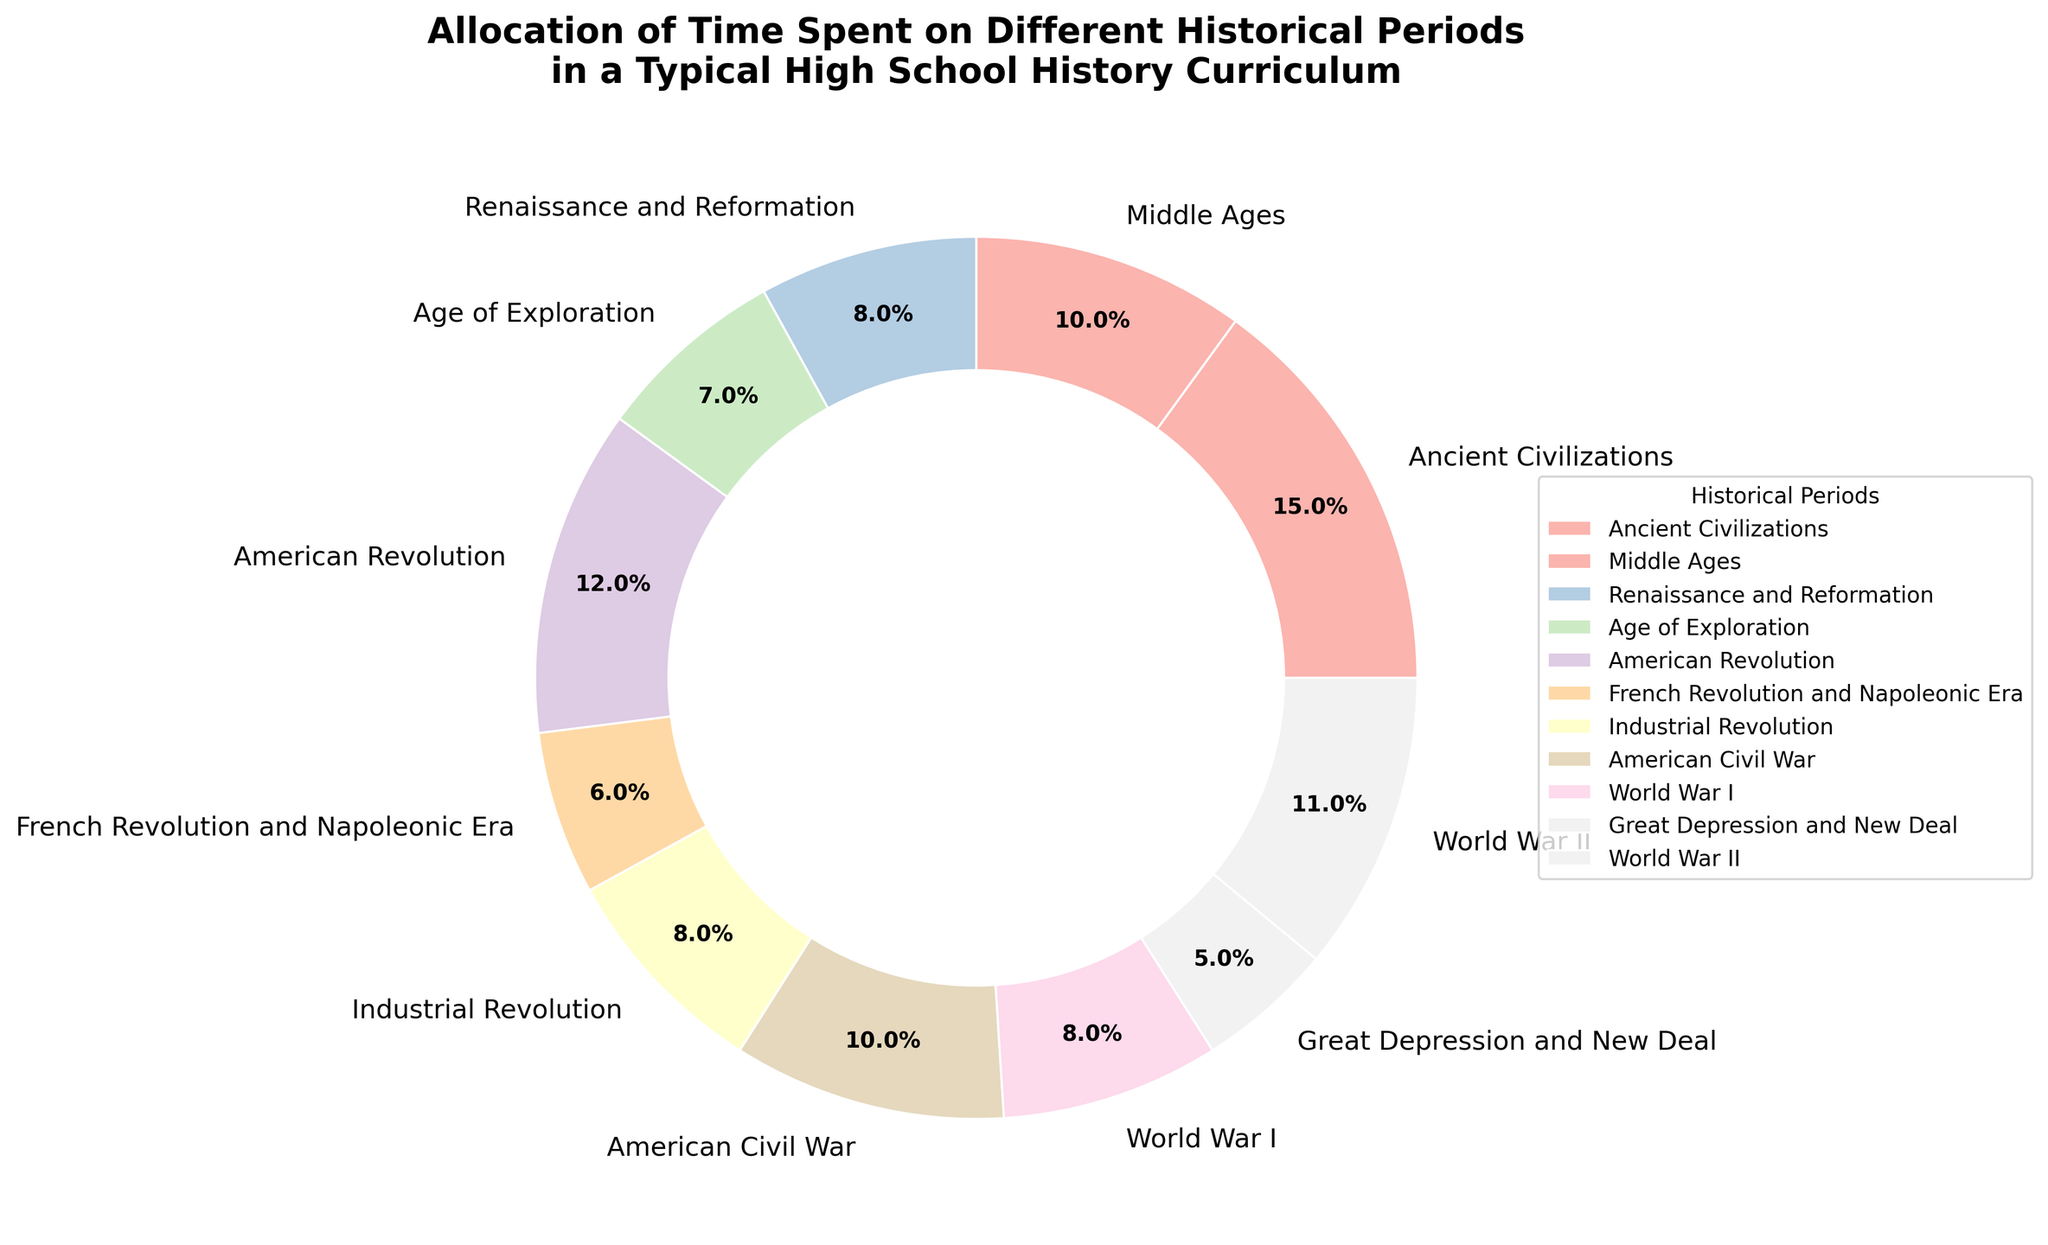What percentage of time is allocated to both World War I and World War II combined? To find this, add the percentages of time allocated to World War I (8%) and World War II (11%). So, 8% + 11% = 19%.
Answer: 19% Which two historical periods have the smallest time allocation and what is their combined percentage? The periods with the smallest allocations are the Great Depression and New Deal (5%) and the French Revolution and Napoleonic Era (6%). Their combined percentage is 5% + 6% = 11%.
Answer: Great Depression and New Deal, French Revolution and Napoleonic Era, 11% Does the time allocation for the Middle Ages exceed that of the Industrial Revolution? Compare the percentages: Middle Ages is 10%, Industrial Revolution is 8%. Since 10% > 8%, the time allocation for the Middle Ages exceeds that of the Industrial Revolution.
Answer: Yes How much more time is spent on Ancient Civilizations compared to the Age of Exploration? Subtract the percentage for the Age of Exploration (7%) from that of Ancient Civilizations (15%). 15% - 7% = 8%.
Answer: 8% Which historical period has a similar time allocation to the American Civil War? The American Civil War is allocated 10% of the time. The closest other time allocation is the Middle Ages, which is also 10%.
Answer: Middle Ages Out of the total time, what fraction is spent on the French Revolution and Napoleonic Era in relation to the American Revolution? Divide the percentage of the French Revolution and Napoleonic Era (6%) by that of the American Revolution (12%). 6% / 12% = 0.5.
Answer: 0.5 Order the historical periods by their allocation from highest to lowest. The order is: Ancient Civilizations (15%), American Revolution (12%), World War II (11%), Middle Ages (10%), American Civil War (10%), Renaissance and Reformation (8%), Industrial Revolution (8%), World War I (8%), Age of Exploration (7%), French Revolution and Napoleonic Era (6%), Great Depression and New Deal (5%).
Answer: Ancient Civilizations, American Revolution, World War II, Middle Ages, American Civil War, Renaissance and Reformation, Industrial Revolution, World War I, Age of Exploration, French Revolution and Napoleonic Era, Great Depression and New Deal How does the time allocated to the Great Depression and New Deal compare to that allocated to the Renaissance and Reformation? Compare the percentages: Great Depression and New Deal is 5%, Renaissance and Reformation is 8%. Since 5% < 8%, less time is allocated to the Great Depression and New Deal.
Answer: Less If you sum the time allocations of all the historical periods spanning from the Renaissance to World War I, what is the total percentage? The periods from the Renaissance to World War I are: Renaissance and Reformation (8%), Age of Exploration (7%), American Revolution (12%), French Revolution and Napoleonic Era (6%), Industrial Revolution (8%), American Civil War (10%), and World War I (8%). Adding these gives: 8% + 7% + 12% + 6% + 8% + 10% + 8% = 59%.
Answer: 59% 